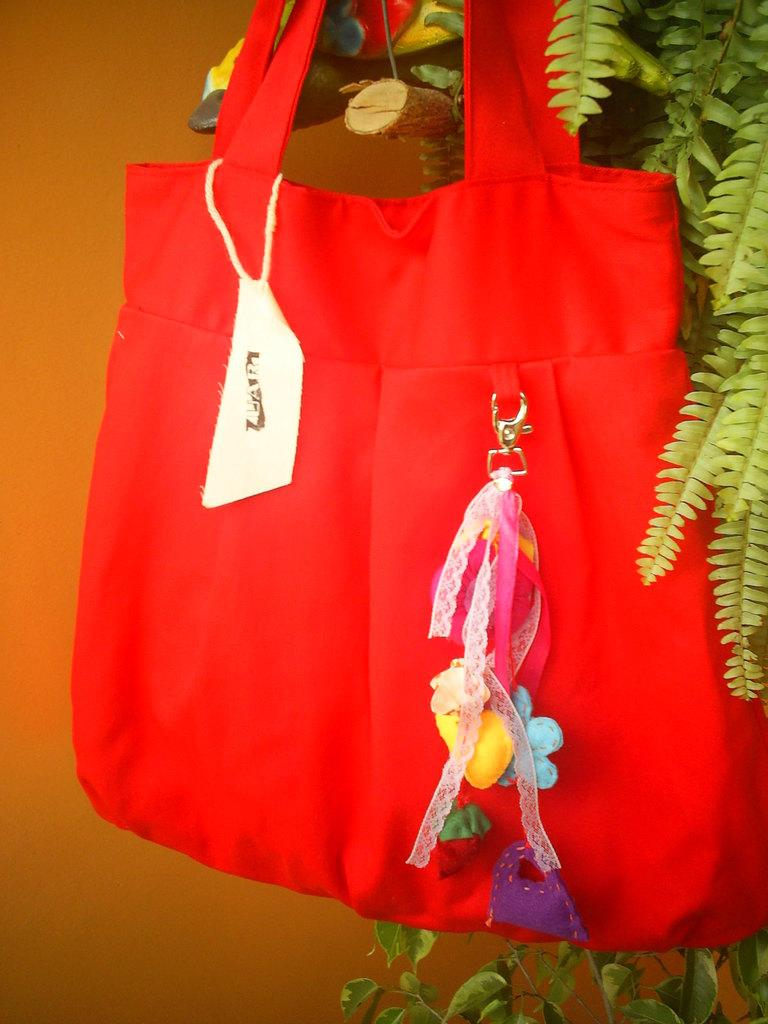What object can be seen in the image? There is a bag in the image. What color is the bag? The bag is red. What type of plant is present in the image? There is a plant with green leaves in the image. What color is the wall in the background? The background of the image includes an orange wall. How many dolls are sitting on the orange wall in the image? There are no dolls present in the image; it only features a bag, a plant, and an orange wall. What time does the clock show in the image? There is no clock present in the image. 